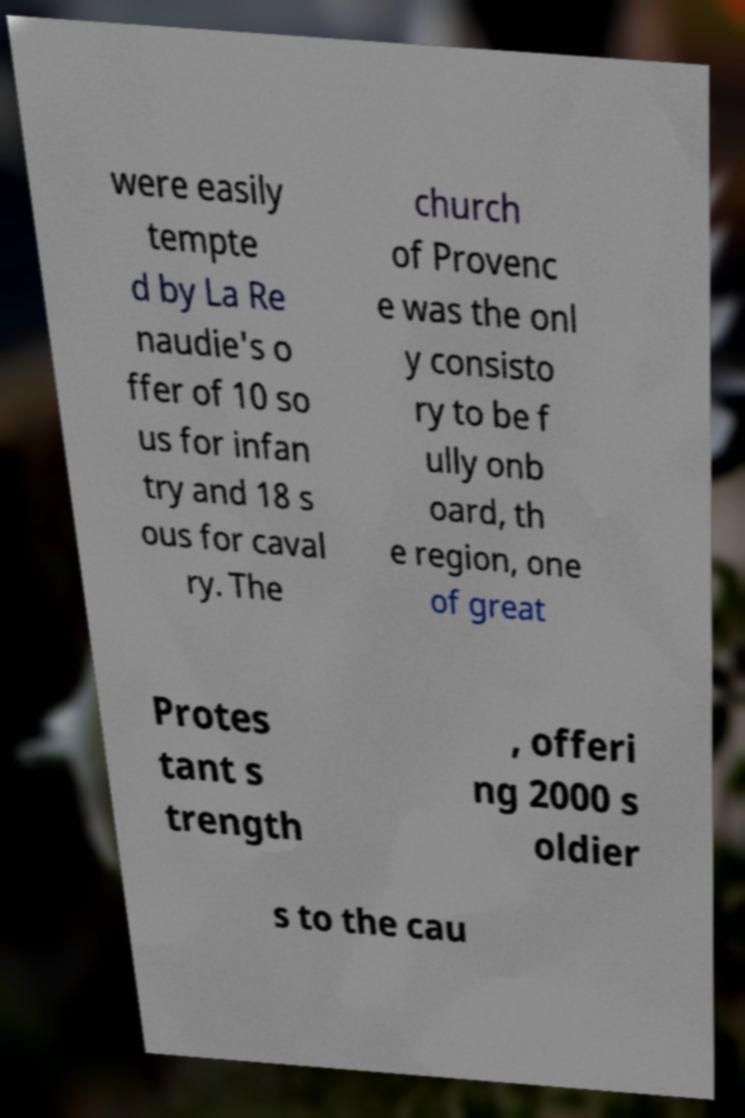Could you extract and type out the text from this image? were easily tempte d by La Re naudie's o ffer of 10 so us for infan try and 18 s ous for caval ry. The church of Provenc e was the onl y consisto ry to be f ully onb oard, th e region, one of great Protes tant s trength , offeri ng 2000 s oldier s to the cau 